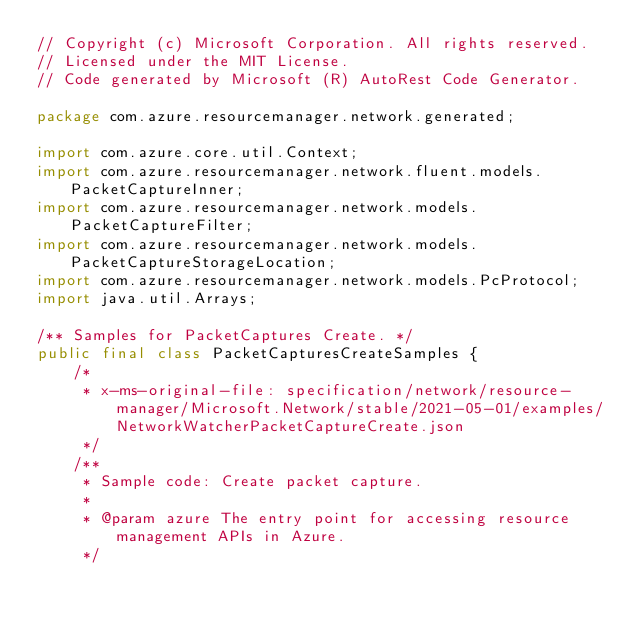Convert code to text. <code><loc_0><loc_0><loc_500><loc_500><_Java_>// Copyright (c) Microsoft Corporation. All rights reserved.
// Licensed under the MIT License.
// Code generated by Microsoft (R) AutoRest Code Generator.

package com.azure.resourcemanager.network.generated;

import com.azure.core.util.Context;
import com.azure.resourcemanager.network.fluent.models.PacketCaptureInner;
import com.azure.resourcemanager.network.models.PacketCaptureFilter;
import com.azure.resourcemanager.network.models.PacketCaptureStorageLocation;
import com.azure.resourcemanager.network.models.PcProtocol;
import java.util.Arrays;

/** Samples for PacketCaptures Create. */
public final class PacketCapturesCreateSamples {
    /*
     * x-ms-original-file: specification/network/resource-manager/Microsoft.Network/stable/2021-05-01/examples/NetworkWatcherPacketCaptureCreate.json
     */
    /**
     * Sample code: Create packet capture.
     *
     * @param azure The entry point for accessing resource management APIs in Azure.
     */</code> 